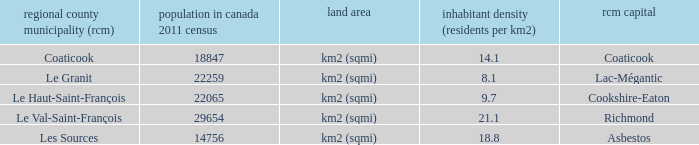What is the land area for the RCM that has a population of 18847? Km2 (sqmi). 